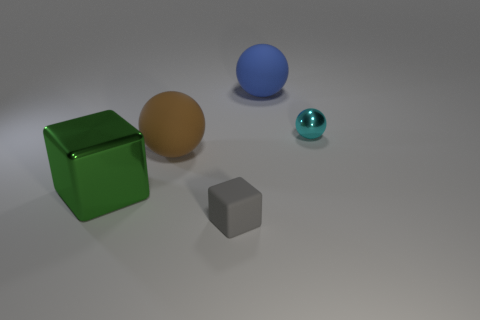Subtract all large rubber balls. How many balls are left? 1 Subtract all cyan spheres. How many spheres are left? 2 Subtract 2 balls. How many balls are left? 1 Add 5 big blue objects. How many objects exist? 10 Subtract all balls. How many objects are left? 2 Subtract all purple spheres. How many red blocks are left? 0 Subtract 0 red cubes. How many objects are left? 5 Subtract all red cubes. Subtract all brown cylinders. How many cubes are left? 2 Subtract all large yellow rubber cubes. Subtract all small gray things. How many objects are left? 4 Add 3 rubber objects. How many rubber objects are left? 6 